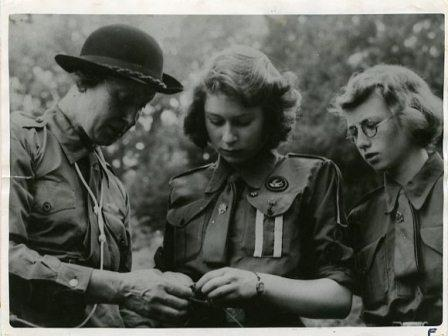What organization is the man's outfit from?

Choices:
A) firefighters
B) paramedics
C) boy scouts
D) navy boy scouts 